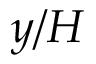Convert formula to latex. <formula><loc_0><loc_0><loc_500><loc_500>y / H</formula> 